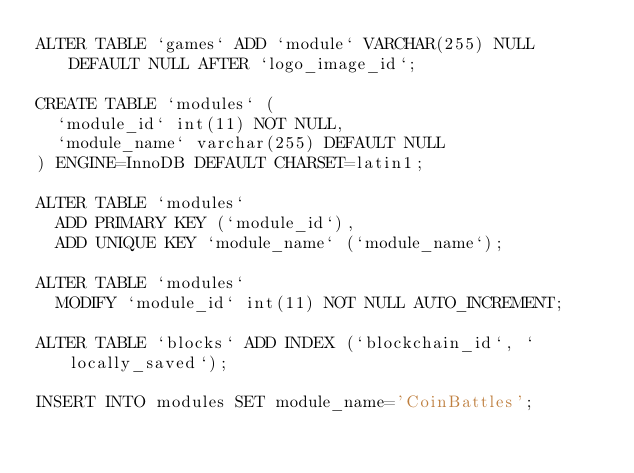<code> <loc_0><loc_0><loc_500><loc_500><_SQL_>ALTER TABLE `games` ADD `module` VARCHAR(255) NULL DEFAULT NULL AFTER `logo_image_id`;

CREATE TABLE `modules` (
  `module_id` int(11) NOT NULL,
  `module_name` varchar(255) DEFAULT NULL
) ENGINE=InnoDB DEFAULT CHARSET=latin1;

ALTER TABLE `modules`
  ADD PRIMARY KEY (`module_id`),
  ADD UNIQUE KEY `module_name` (`module_name`);

ALTER TABLE `modules`
  MODIFY `module_id` int(11) NOT NULL AUTO_INCREMENT;

ALTER TABLE `blocks` ADD INDEX (`blockchain_id`, `locally_saved`);

INSERT INTO modules SET module_name='CoinBattles';</code> 